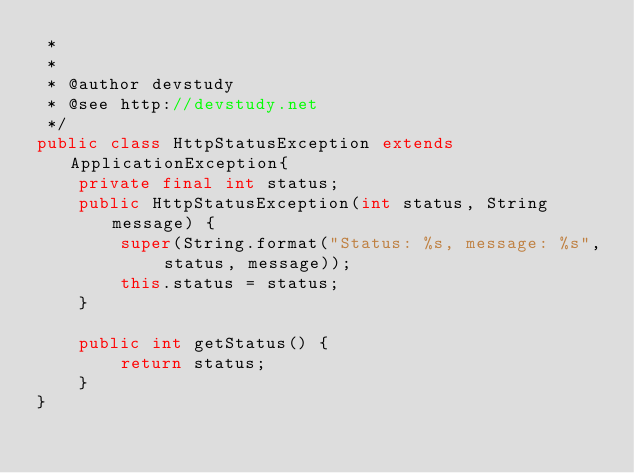Convert code to text. <code><loc_0><loc_0><loc_500><loc_500><_Java_> * 
 * 
 * @author devstudy
 * @see http://devstudy.net
 */
public class HttpStatusException extends ApplicationException{
    private final int status;
    public HttpStatusException(int status, String message) {
        super(String.format("Status: %s, message: %s", status, message));
        this.status = status;
    }

    public int getStatus() {
        return status;
    }
}
</code> 